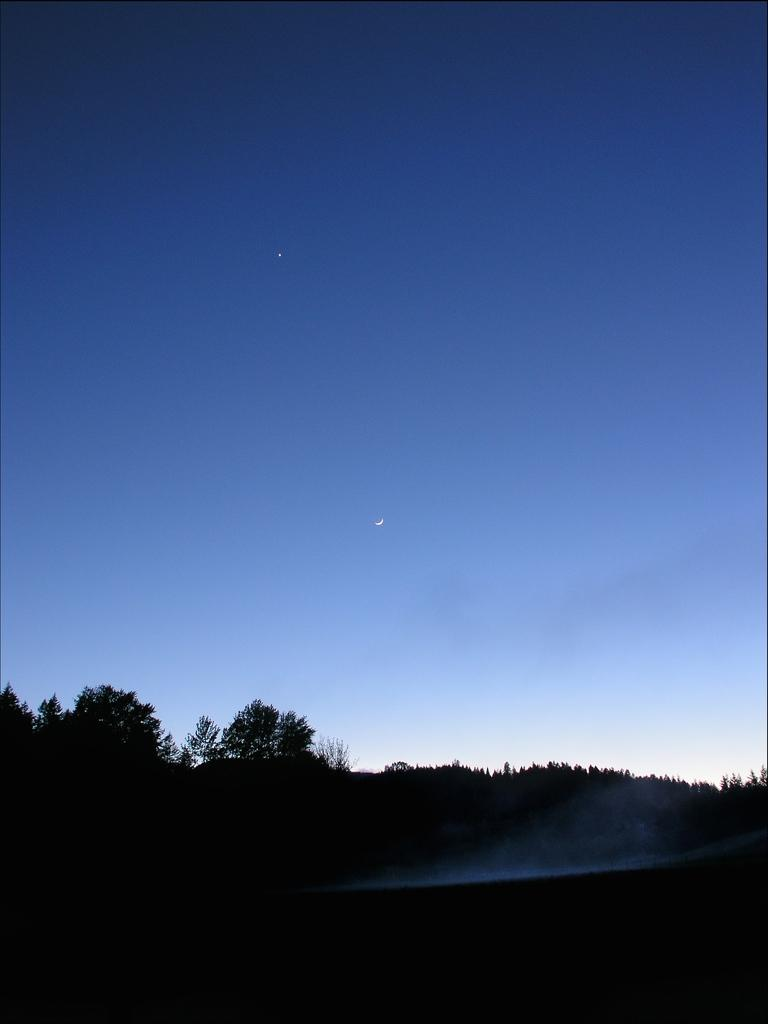What time of day was the image taken? The image was taken during night time. What can be seen at the bottom of the image? There are trees at the bottom of the image. What celestial body is in the center of the image? The moon is in the center of the image. What is present at the top of the image? There is a star at the top of the image. What type of crime is being committed in the image? There is no indication of any crime being committed in the image; it primarily features the moon, a star, and trees. What season is depicted in the image? The image does not depict a specific season; it was taken at night, and the trees and celestial bodies are the main focus. 